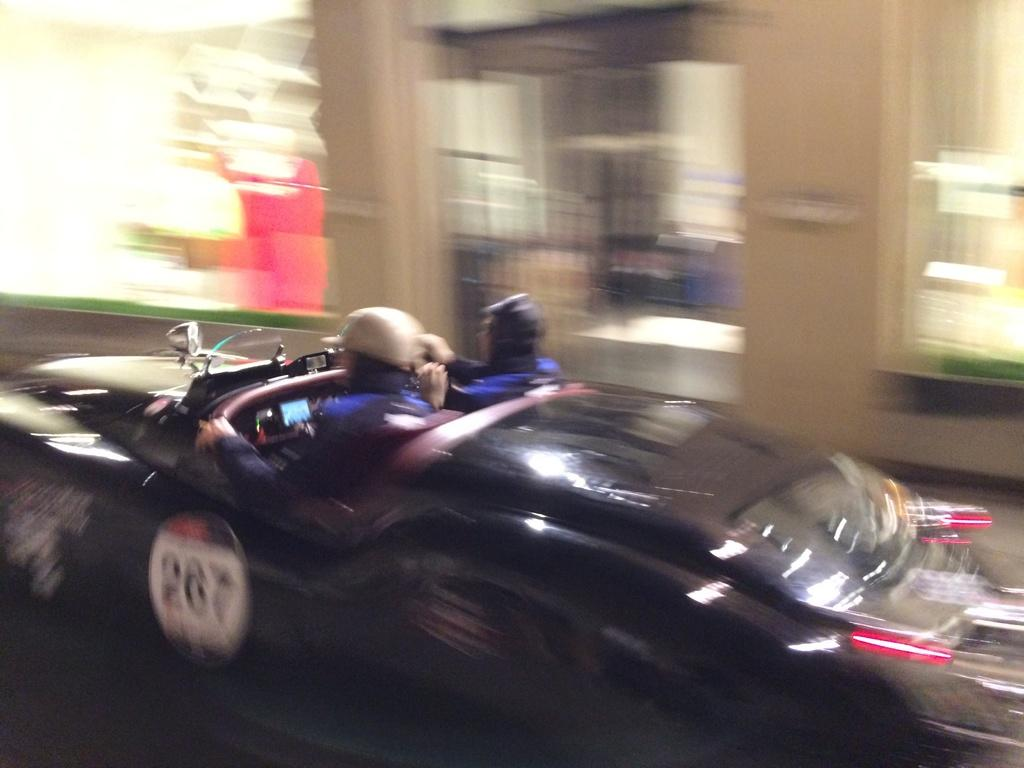How many people are in the car in the image? There are two persons in a car in the foreground of the image. What time of day does the image appear to be taken? The image is likely taken during the night. What can be seen in the background of the image? There are buildings and lights visible in the background of the image. What type of spiders can be seen crawling on the branch in the image? There is no branch or spiders present in the image. 